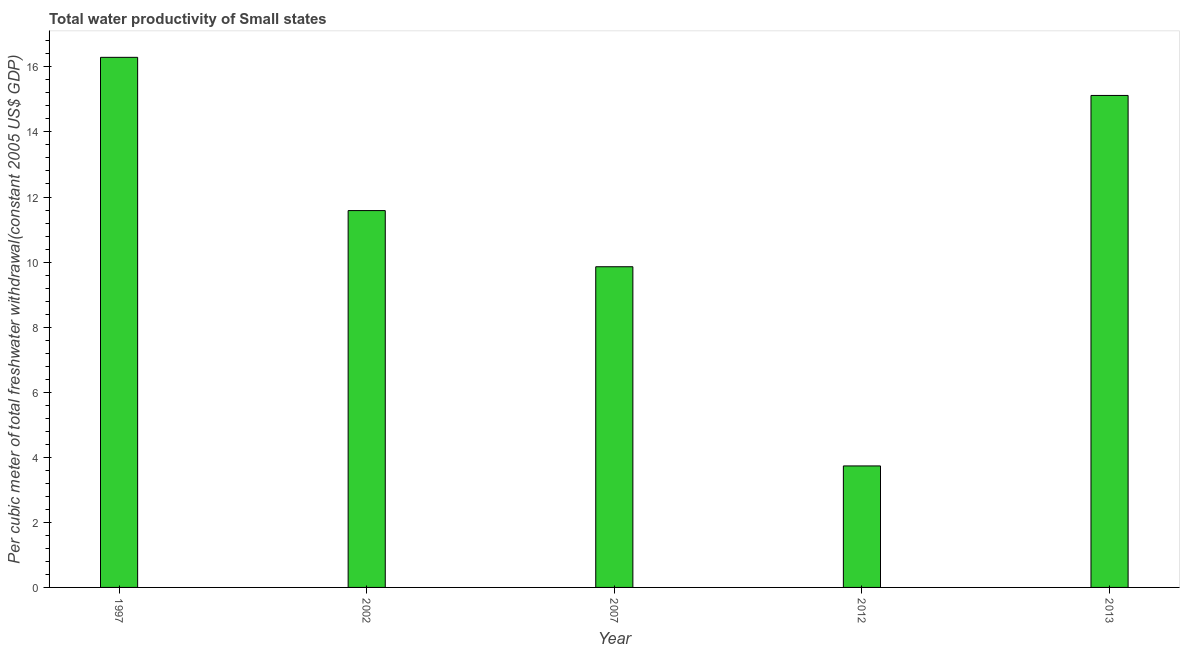Does the graph contain grids?
Offer a very short reply. No. What is the title of the graph?
Give a very brief answer. Total water productivity of Small states. What is the label or title of the X-axis?
Keep it short and to the point. Year. What is the label or title of the Y-axis?
Give a very brief answer. Per cubic meter of total freshwater withdrawal(constant 2005 US$ GDP). What is the total water productivity in 2007?
Keep it short and to the point. 9.86. Across all years, what is the maximum total water productivity?
Give a very brief answer. 16.29. Across all years, what is the minimum total water productivity?
Offer a terse response. 3.73. In which year was the total water productivity maximum?
Offer a very short reply. 1997. In which year was the total water productivity minimum?
Offer a very short reply. 2012. What is the sum of the total water productivity?
Offer a terse response. 56.59. What is the difference between the total water productivity in 2007 and 2012?
Keep it short and to the point. 6.12. What is the average total water productivity per year?
Your answer should be compact. 11.32. What is the median total water productivity?
Provide a short and direct response. 11.58. Do a majority of the years between 2002 and 2007 (inclusive) have total water productivity greater than 0.8 US$?
Ensure brevity in your answer.  Yes. What is the ratio of the total water productivity in 2002 to that in 2013?
Keep it short and to the point. 0.77. Is the total water productivity in 2002 less than that in 2013?
Your response must be concise. Yes. What is the difference between the highest and the second highest total water productivity?
Provide a succinct answer. 1.17. Is the sum of the total water productivity in 2007 and 2013 greater than the maximum total water productivity across all years?
Keep it short and to the point. Yes. What is the difference between the highest and the lowest total water productivity?
Offer a terse response. 12.56. In how many years, is the total water productivity greater than the average total water productivity taken over all years?
Provide a short and direct response. 3. How many bars are there?
Your response must be concise. 5. Are all the bars in the graph horizontal?
Offer a very short reply. No. What is the difference between two consecutive major ticks on the Y-axis?
Your answer should be compact. 2. Are the values on the major ticks of Y-axis written in scientific E-notation?
Offer a very short reply. No. What is the Per cubic meter of total freshwater withdrawal(constant 2005 US$ GDP) in 1997?
Provide a short and direct response. 16.29. What is the Per cubic meter of total freshwater withdrawal(constant 2005 US$ GDP) in 2002?
Make the answer very short. 11.58. What is the Per cubic meter of total freshwater withdrawal(constant 2005 US$ GDP) of 2007?
Offer a very short reply. 9.86. What is the Per cubic meter of total freshwater withdrawal(constant 2005 US$ GDP) in 2012?
Ensure brevity in your answer.  3.73. What is the Per cubic meter of total freshwater withdrawal(constant 2005 US$ GDP) in 2013?
Offer a very short reply. 15.12. What is the difference between the Per cubic meter of total freshwater withdrawal(constant 2005 US$ GDP) in 1997 and 2002?
Your answer should be compact. 4.71. What is the difference between the Per cubic meter of total freshwater withdrawal(constant 2005 US$ GDP) in 1997 and 2007?
Your answer should be very brief. 6.44. What is the difference between the Per cubic meter of total freshwater withdrawal(constant 2005 US$ GDP) in 1997 and 2012?
Ensure brevity in your answer.  12.56. What is the difference between the Per cubic meter of total freshwater withdrawal(constant 2005 US$ GDP) in 1997 and 2013?
Your response must be concise. 1.17. What is the difference between the Per cubic meter of total freshwater withdrawal(constant 2005 US$ GDP) in 2002 and 2007?
Make the answer very short. 1.73. What is the difference between the Per cubic meter of total freshwater withdrawal(constant 2005 US$ GDP) in 2002 and 2012?
Your answer should be very brief. 7.85. What is the difference between the Per cubic meter of total freshwater withdrawal(constant 2005 US$ GDP) in 2002 and 2013?
Provide a short and direct response. -3.54. What is the difference between the Per cubic meter of total freshwater withdrawal(constant 2005 US$ GDP) in 2007 and 2012?
Keep it short and to the point. 6.12. What is the difference between the Per cubic meter of total freshwater withdrawal(constant 2005 US$ GDP) in 2007 and 2013?
Give a very brief answer. -5.27. What is the difference between the Per cubic meter of total freshwater withdrawal(constant 2005 US$ GDP) in 2012 and 2013?
Give a very brief answer. -11.39. What is the ratio of the Per cubic meter of total freshwater withdrawal(constant 2005 US$ GDP) in 1997 to that in 2002?
Your response must be concise. 1.41. What is the ratio of the Per cubic meter of total freshwater withdrawal(constant 2005 US$ GDP) in 1997 to that in 2007?
Your answer should be compact. 1.65. What is the ratio of the Per cubic meter of total freshwater withdrawal(constant 2005 US$ GDP) in 1997 to that in 2012?
Provide a succinct answer. 4.36. What is the ratio of the Per cubic meter of total freshwater withdrawal(constant 2005 US$ GDP) in 1997 to that in 2013?
Provide a short and direct response. 1.08. What is the ratio of the Per cubic meter of total freshwater withdrawal(constant 2005 US$ GDP) in 2002 to that in 2007?
Keep it short and to the point. 1.18. What is the ratio of the Per cubic meter of total freshwater withdrawal(constant 2005 US$ GDP) in 2002 to that in 2012?
Ensure brevity in your answer.  3.1. What is the ratio of the Per cubic meter of total freshwater withdrawal(constant 2005 US$ GDP) in 2002 to that in 2013?
Ensure brevity in your answer.  0.77. What is the ratio of the Per cubic meter of total freshwater withdrawal(constant 2005 US$ GDP) in 2007 to that in 2012?
Offer a terse response. 2.64. What is the ratio of the Per cubic meter of total freshwater withdrawal(constant 2005 US$ GDP) in 2007 to that in 2013?
Your answer should be very brief. 0.65. What is the ratio of the Per cubic meter of total freshwater withdrawal(constant 2005 US$ GDP) in 2012 to that in 2013?
Keep it short and to the point. 0.25. 